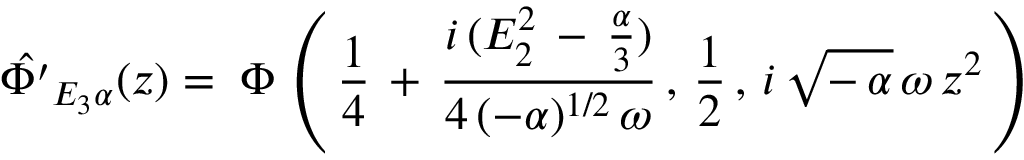Convert formula to latex. <formula><loc_0><loc_0><loc_500><loc_500>\hat { \Phi ^ { \prime } } _ { E _ { 3 } \alpha } ( z ) = \, \Phi \, \left ( \, \frac { 1 } { 4 } \, + \, \frac { i \, ( E _ { 2 } ^ { 2 } \, - \, \frac { \alpha } { 3 } ) } { 4 \, ( - \alpha ) ^ { 1 / 2 } \, \omega } \, , \, \frac { 1 } { 2 } \, , \, i \, \sqrt { - \, \alpha } \, \omega \, z ^ { 2 } \, \right ) \,</formula> 